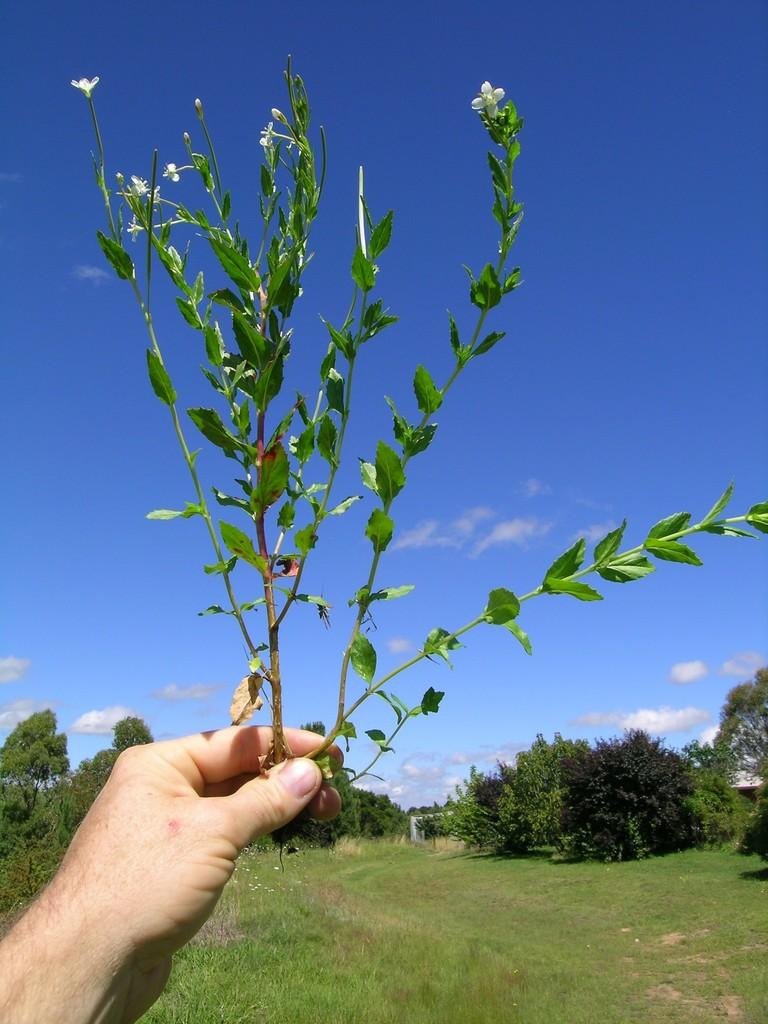What is the person's hand holding in the image? There is a person's hand holding a plant in the image. What type of vegetation can be seen in the image? There is grass visible in the image. What can be seen in the background of the image? There are trees and a blue sky with clouds in the background of the image. What type of band is playing in the background of the image? There is no band present in the image; it features a person holding a plant with a grassy area and trees in the background. 